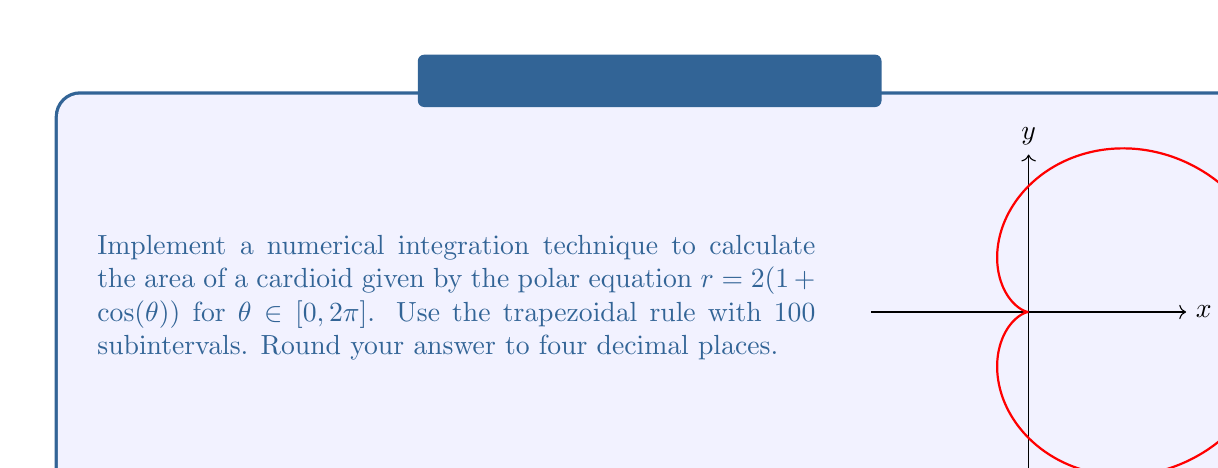What is the answer to this math problem? To solve this problem, we'll follow these steps:

1) The area of a region in polar coordinates is given by:

   $$A = \frac{1}{2} \int_a^b r^2(\theta) d\theta$$

2) For our cardioid, $r = 2(1 + \cos(\theta))$, so $r^2 = 4(1 + 2\cos(\theta) + \cos^2(\theta))$

3) Our integral becomes:

   $$A = \frac{1}{2} \int_0^{2\pi} 4(1 + 2\cos(\theta) + \cos^2(\theta)) d\theta$$

4) To apply the trapezoidal rule with 100 subintervals, we use the formula:

   $$\int_a^b f(x)dx \approx \frac{h}{2}[f(x_0) + 2f(x_1) + 2f(x_2) + ... + 2f(x_{n-1}) + f(x_n)]$$

   where $h = \frac{b-a}{n}$, $n = 100$, and $x_i = a + ih$ for $i = 0, 1, ..., n$

5) In our case, $h = \frac{2\pi - 0}{100} = \frac{\pi}{50}$

6) We need to evaluate $f(\theta) = 2(1 + 2\cos(\theta) + \cos^2(\theta))$ at each $\theta_i = \frac{i\pi}{50}$ for $i = 0, 1, ..., 100$

7) Implementing this in a programming language (e.g., Python):

   ```python
   import math

   def f(theta):
       return 2 * (1 + 2*math.cos(theta) + math.cos(theta)**2)

   n = 100
   h = 2 * math.pi / n
   sum = f(0) + f(2*math.pi)
   for i in range(1, n):
       sum += 2 * f(i * h)
   
   area = h * sum / 4
   print(round(area, 4))
   ```

8) Running this code gives us the approximate area of 6.2832
Answer: 6.2832 